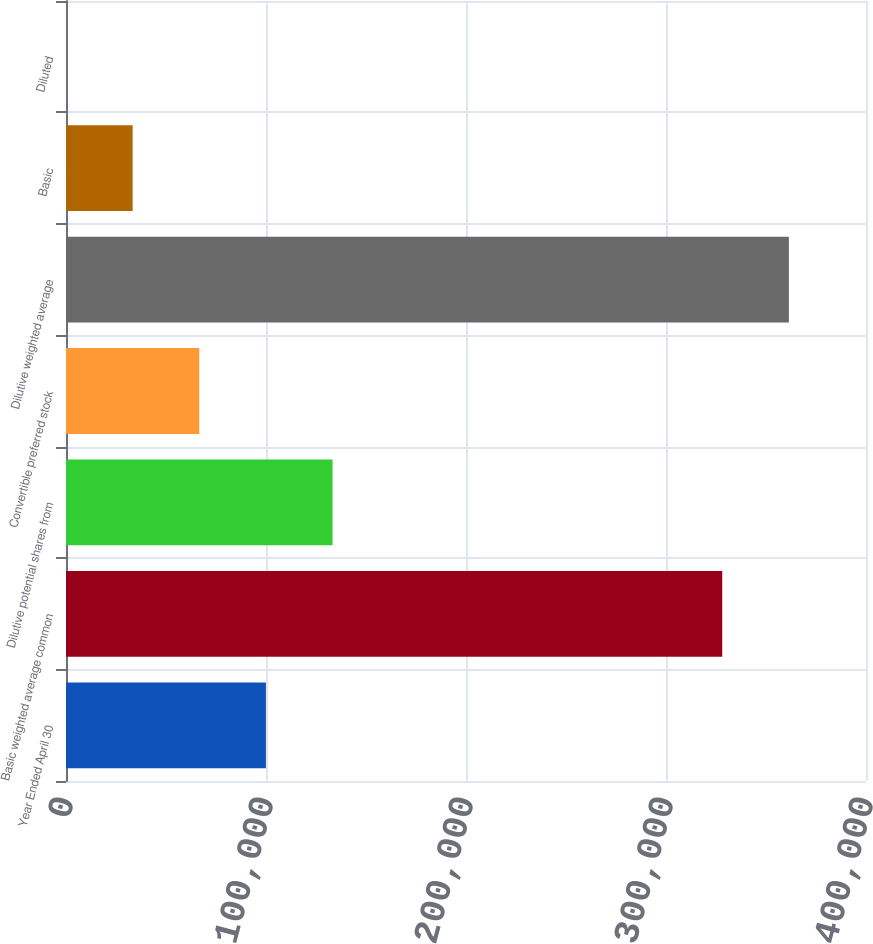Convert chart. <chart><loc_0><loc_0><loc_500><loc_500><bar_chart><fcel>Year Ended April 30<fcel>Basic weighted average common<fcel>Dilutive potential shares from<fcel>Convertible preferred stock<fcel>Dilutive weighted average<fcel>Basic<fcel>Diluted<nl><fcel>99956.7<fcel>328118<fcel>133275<fcel>66638.1<fcel>361437<fcel>33319.5<fcel>0.89<nl></chart> 